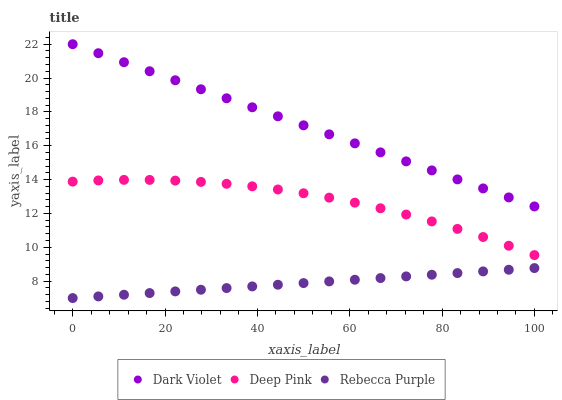Does Rebecca Purple have the minimum area under the curve?
Answer yes or no. Yes. Does Dark Violet have the maximum area under the curve?
Answer yes or no. Yes. Does Dark Violet have the minimum area under the curve?
Answer yes or no. No. Does Rebecca Purple have the maximum area under the curve?
Answer yes or no. No. Is Dark Violet the smoothest?
Answer yes or no. Yes. Is Deep Pink the roughest?
Answer yes or no. Yes. Is Rebecca Purple the smoothest?
Answer yes or no. No. Is Rebecca Purple the roughest?
Answer yes or no. No. Does Rebecca Purple have the lowest value?
Answer yes or no. Yes. Does Dark Violet have the lowest value?
Answer yes or no. No. Does Dark Violet have the highest value?
Answer yes or no. Yes. Does Rebecca Purple have the highest value?
Answer yes or no. No. Is Rebecca Purple less than Deep Pink?
Answer yes or no. Yes. Is Dark Violet greater than Rebecca Purple?
Answer yes or no. Yes. Does Rebecca Purple intersect Deep Pink?
Answer yes or no. No. 